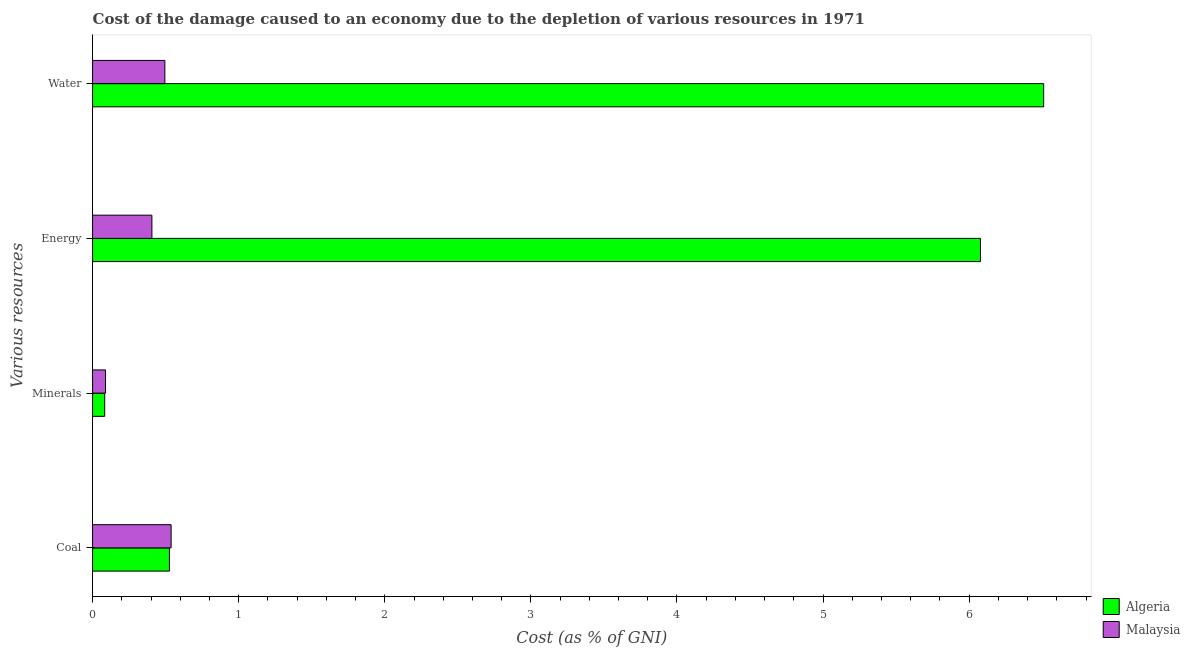How many different coloured bars are there?
Give a very brief answer. 2. How many groups of bars are there?
Keep it short and to the point. 4. How many bars are there on the 3rd tick from the bottom?
Ensure brevity in your answer.  2. What is the label of the 4th group of bars from the top?
Your answer should be very brief. Coal. What is the cost of damage due to depletion of minerals in Malaysia?
Keep it short and to the point. 0.09. Across all countries, what is the maximum cost of damage due to depletion of energy?
Give a very brief answer. 6.08. Across all countries, what is the minimum cost of damage due to depletion of minerals?
Give a very brief answer. 0.08. In which country was the cost of damage due to depletion of coal maximum?
Provide a short and direct response. Malaysia. In which country was the cost of damage due to depletion of energy minimum?
Your answer should be compact. Malaysia. What is the total cost of damage due to depletion of minerals in the graph?
Provide a short and direct response. 0.17. What is the difference between the cost of damage due to depletion of water in Algeria and that in Malaysia?
Provide a succinct answer. 6.01. What is the difference between the cost of damage due to depletion of water in Algeria and the cost of damage due to depletion of energy in Malaysia?
Your response must be concise. 6.1. What is the average cost of damage due to depletion of energy per country?
Keep it short and to the point. 3.24. What is the difference between the cost of damage due to depletion of coal and cost of damage due to depletion of energy in Malaysia?
Make the answer very short. 0.13. What is the ratio of the cost of damage due to depletion of energy in Algeria to that in Malaysia?
Make the answer very short. 14.96. Is the difference between the cost of damage due to depletion of coal in Malaysia and Algeria greater than the difference between the cost of damage due to depletion of energy in Malaysia and Algeria?
Offer a very short reply. Yes. What is the difference between the highest and the second highest cost of damage due to depletion of minerals?
Provide a succinct answer. 0.01. What is the difference between the highest and the lowest cost of damage due to depletion of coal?
Your answer should be very brief. 0.01. In how many countries, is the cost of damage due to depletion of energy greater than the average cost of damage due to depletion of energy taken over all countries?
Give a very brief answer. 1. Is the sum of the cost of damage due to depletion of energy in Malaysia and Algeria greater than the maximum cost of damage due to depletion of minerals across all countries?
Keep it short and to the point. Yes. What does the 1st bar from the top in Minerals represents?
Offer a terse response. Malaysia. What does the 2nd bar from the bottom in Energy represents?
Give a very brief answer. Malaysia. How many bars are there?
Your response must be concise. 8. Are all the bars in the graph horizontal?
Keep it short and to the point. Yes. How many countries are there in the graph?
Provide a short and direct response. 2. What is the difference between two consecutive major ticks on the X-axis?
Ensure brevity in your answer.  1. Where does the legend appear in the graph?
Your answer should be very brief. Bottom right. How many legend labels are there?
Make the answer very short. 2. How are the legend labels stacked?
Give a very brief answer. Vertical. What is the title of the graph?
Provide a succinct answer. Cost of the damage caused to an economy due to the depletion of various resources in 1971 . What is the label or title of the X-axis?
Ensure brevity in your answer.  Cost (as % of GNI). What is the label or title of the Y-axis?
Offer a very short reply. Various resources. What is the Cost (as % of GNI) of Algeria in Coal?
Offer a very short reply. 0.53. What is the Cost (as % of GNI) of Malaysia in Coal?
Ensure brevity in your answer.  0.54. What is the Cost (as % of GNI) in Algeria in Minerals?
Offer a terse response. 0.08. What is the Cost (as % of GNI) in Malaysia in Minerals?
Your answer should be very brief. 0.09. What is the Cost (as % of GNI) in Algeria in Energy?
Provide a short and direct response. 6.08. What is the Cost (as % of GNI) in Malaysia in Energy?
Make the answer very short. 0.41. What is the Cost (as % of GNI) of Algeria in Water?
Provide a succinct answer. 6.51. What is the Cost (as % of GNI) in Malaysia in Water?
Keep it short and to the point. 0.49. Across all Various resources, what is the maximum Cost (as % of GNI) of Algeria?
Your answer should be very brief. 6.51. Across all Various resources, what is the maximum Cost (as % of GNI) in Malaysia?
Make the answer very short. 0.54. Across all Various resources, what is the minimum Cost (as % of GNI) in Algeria?
Give a very brief answer. 0.08. Across all Various resources, what is the minimum Cost (as % of GNI) in Malaysia?
Give a very brief answer. 0.09. What is the total Cost (as % of GNI) in Algeria in the graph?
Your response must be concise. 13.2. What is the total Cost (as % of GNI) in Malaysia in the graph?
Your answer should be very brief. 1.53. What is the difference between the Cost (as % of GNI) of Algeria in Coal and that in Minerals?
Your response must be concise. 0.44. What is the difference between the Cost (as % of GNI) of Malaysia in Coal and that in Minerals?
Make the answer very short. 0.45. What is the difference between the Cost (as % of GNI) in Algeria in Coal and that in Energy?
Provide a short and direct response. -5.55. What is the difference between the Cost (as % of GNI) in Malaysia in Coal and that in Energy?
Provide a short and direct response. 0.13. What is the difference between the Cost (as % of GNI) of Algeria in Coal and that in Water?
Your response must be concise. -5.98. What is the difference between the Cost (as % of GNI) of Malaysia in Coal and that in Water?
Provide a succinct answer. 0.04. What is the difference between the Cost (as % of GNI) in Algeria in Minerals and that in Energy?
Ensure brevity in your answer.  -5.99. What is the difference between the Cost (as % of GNI) of Malaysia in Minerals and that in Energy?
Provide a short and direct response. -0.32. What is the difference between the Cost (as % of GNI) in Algeria in Minerals and that in Water?
Make the answer very short. -6.43. What is the difference between the Cost (as % of GNI) in Malaysia in Minerals and that in Water?
Give a very brief answer. -0.41. What is the difference between the Cost (as % of GNI) of Algeria in Energy and that in Water?
Your response must be concise. -0.43. What is the difference between the Cost (as % of GNI) of Malaysia in Energy and that in Water?
Make the answer very short. -0.09. What is the difference between the Cost (as % of GNI) of Algeria in Coal and the Cost (as % of GNI) of Malaysia in Minerals?
Your answer should be compact. 0.44. What is the difference between the Cost (as % of GNI) in Algeria in Coal and the Cost (as % of GNI) in Malaysia in Energy?
Provide a succinct answer. 0.12. What is the difference between the Cost (as % of GNI) in Algeria in Coal and the Cost (as % of GNI) in Malaysia in Water?
Ensure brevity in your answer.  0.03. What is the difference between the Cost (as % of GNI) of Algeria in Minerals and the Cost (as % of GNI) of Malaysia in Energy?
Your response must be concise. -0.32. What is the difference between the Cost (as % of GNI) of Algeria in Minerals and the Cost (as % of GNI) of Malaysia in Water?
Keep it short and to the point. -0.41. What is the difference between the Cost (as % of GNI) of Algeria in Energy and the Cost (as % of GNI) of Malaysia in Water?
Give a very brief answer. 5.58. What is the average Cost (as % of GNI) of Algeria per Various resources?
Provide a short and direct response. 3.3. What is the average Cost (as % of GNI) of Malaysia per Various resources?
Provide a succinct answer. 0.38. What is the difference between the Cost (as % of GNI) of Algeria and Cost (as % of GNI) of Malaysia in Coal?
Provide a succinct answer. -0.01. What is the difference between the Cost (as % of GNI) of Algeria and Cost (as % of GNI) of Malaysia in Minerals?
Keep it short and to the point. -0.01. What is the difference between the Cost (as % of GNI) in Algeria and Cost (as % of GNI) in Malaysia in Energy?
Provide a short and direct response. 5.67. What is the difference between the Cost (as % of GNI) in Algeria and Cost (as % of GNI) in Malaysia in Water?
Give a very brief answer. 6.01. What is the ratio of the Cost (as % of GNI) of Algeria in Coal to that in Minerals?
Give a very brief answer. 6.32. What is the ratio of the Cost (as % of GNI) of Malaysia in Coal to that in Minerals?
Provide a succinct answer. 6.06. What is the ratio of the Cost (as % of GNI) of Algeria in Coal to that in Energy?
Ensure brevity in your answer.  0.09. What is the ratio of the Cost (as % of GNI) in Malaysia in Coal to that in Energy?
Give a very brief answer. 1.32. What is the ratio of the Cost (as % of GNI) in Algeria in Coal to that in Water?
Your response must be concise. 0.08. What is the ratio of the Cost (as % of GNI) of Malaysia in Coal to that in Water?
Your answer should be very brief. 1.09. What is the ratio of the Cost (as % of GNI) of Algeria in Minerals to that in Energy?
Your answer should be compact. 0.01. What is the ratio of the Cost (as % of GNI) of Malaysia in Minerals to that in Energy?
Offer a terse response. 0.22. What is the ratio of the Cost (as % of GNI) of Algeria in Minerals to that in Water?
Offer a very short reply. 0.01. What is the ratio of the Cost (as % of GNI) in Malaysia in Minerals to that in Water?
Keep it short and to the point. 0.18. What is the ratio of the Cost (as % of GNI) in Algeria in Energy to that in Water?
Offer a very short reply. 0.93. What is the ratio of the Cost (as % of GNI) in Malaysia in Energy to that in Water?
Keep it short and to the point. 0.82. What is the difference between the highest and the second highest Cost (as % of GNI) in Algeria?
Your answer should be compact. 0.43. What is the difference between the highest and the second highest Cost (as % of GNI) in Malaysia?
Your answer should be compact. 0.04. What is the difference between the highest and the lowest Cost (as % of GNI) in Algeria?
Offer a very short reply. 6.43. What is the difference between the highest and the lowest Cost (as % of GNI) of Malaysia?
Offer a terse response. 0.45. 